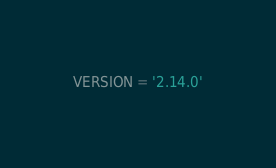Convert code to text. <code><loc_0><loc_0><loc_500><loc_500><_Python_>VERSION = '2.14.0'
</code> 